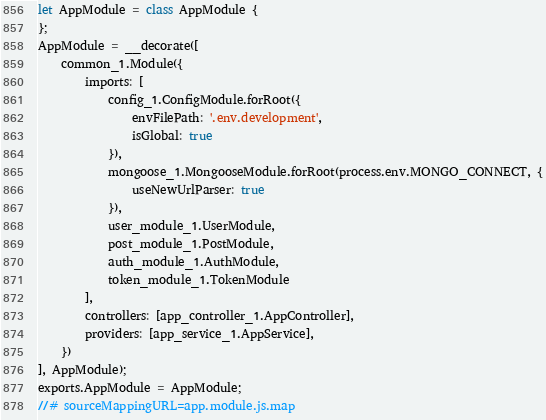Convert code to text. <code><loc_0><loc_0><loc_500><loc_500><_JavaScript_>let AppModule = class AppModule {
};
AppModule = __decorate([
    common_1.Module({
        imports: [
            config_1.ConfigModule.forRoot({
                envFilePath: '.env.development',
                isGlobal: true
            }),
            mongoose_1.MongooseModule.forRoot(process.env.MONGO_CONNECT, {
                useNewUrlParser: true
            }),
            user_module_1.UserModule,
            post_module_1.PostModule,
            auth_module_1.AuthModule,
            token_module_1.TokenModule
        ],
        controllers: [app_controller_1.AppController],
        providers: [app_service_1.AppService],
    })
], AppModule);
exports.AppModule = AppModule;
//# sourceMappingURL=app.module.js.map</code> 